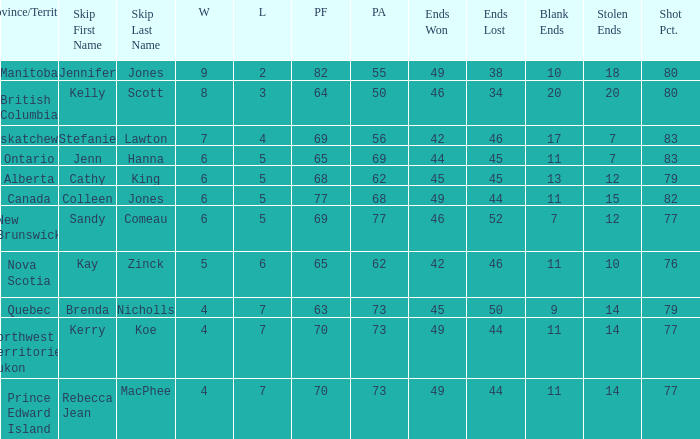What is the total number of ends won when the locale is Northwest Territories Yukon? 1.0. 